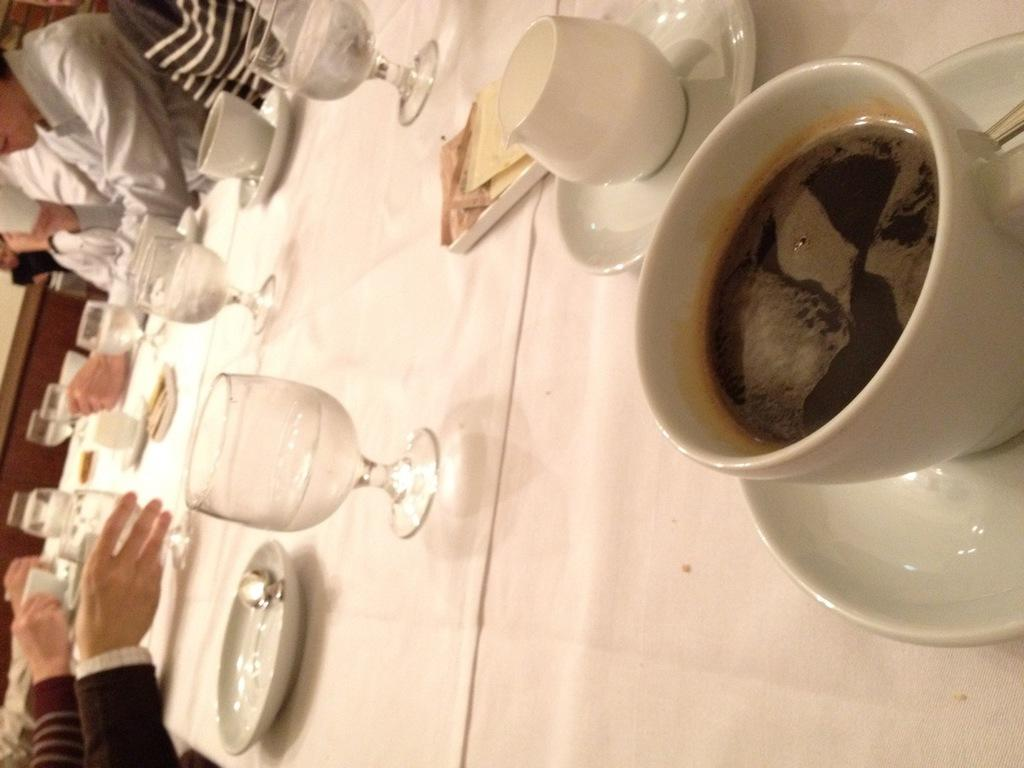What is covering the table in the image? There is a table with a white cloth in the image. What types of containers are on the table? There are glasses and cups on the table. What else can be found on the table? There are plates and other objects on the table. Who is present around the table? There are people sitting around the table. Can you see a toad sitting on the table in the image? No, there is no toad present in the image. Are the people sitting around the table parents of the children in the image? There is no information about the relationship between the people in the image, so we cannot determine if they are parents. 